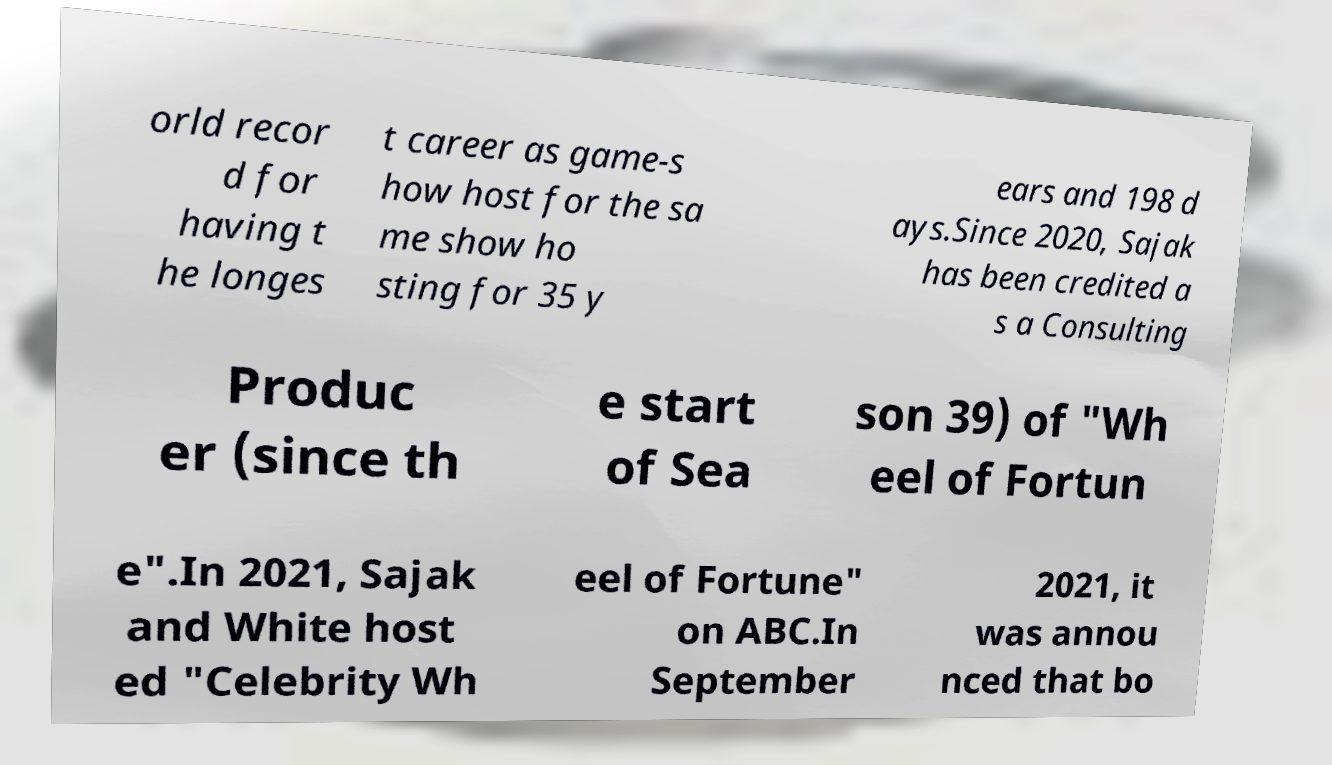There's text embedded in this image that I need extracted. Can you transcribe it verbatim? orld recor d for having t he longes t career as game-s how host for the sa me show ho sting for 35 y ears and 198 d ays.Since 2020, Sajak has been credited a s a Consulting Produc er (since th e start of Sea son 39) of "Wh eel of Fortun e".In 2021, Sajak and White host ed "Celebrity Wh eel of Fortune" on ABC.In September 2021, it was annou nced that bo 